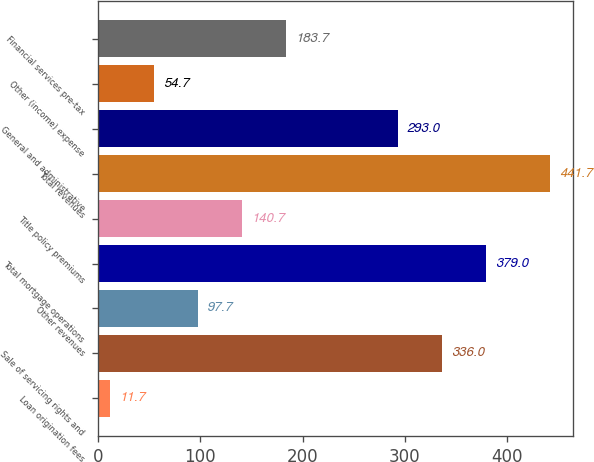Convert chart to OTSL. <chart><loc_0><loc_0><loc_500><loc_500><bar_chart><fcel>Loan origination fees<fcel>Sale of servicing rights and<fcel>Other revenues<fcel>Total mortgage operations<fcel>Title policy premiums<fcel>Total revenues<fcel>General and administrative<fcel>Other (income) expense<fcel>Financial services pre-tax<nl><fcel>11.7<fcel>336<fcel>97.7<fcel>379<fcel>140.7<fcel>441.7<fcel>293<fcel>54.7<fcel>183.7<nl></chart> 